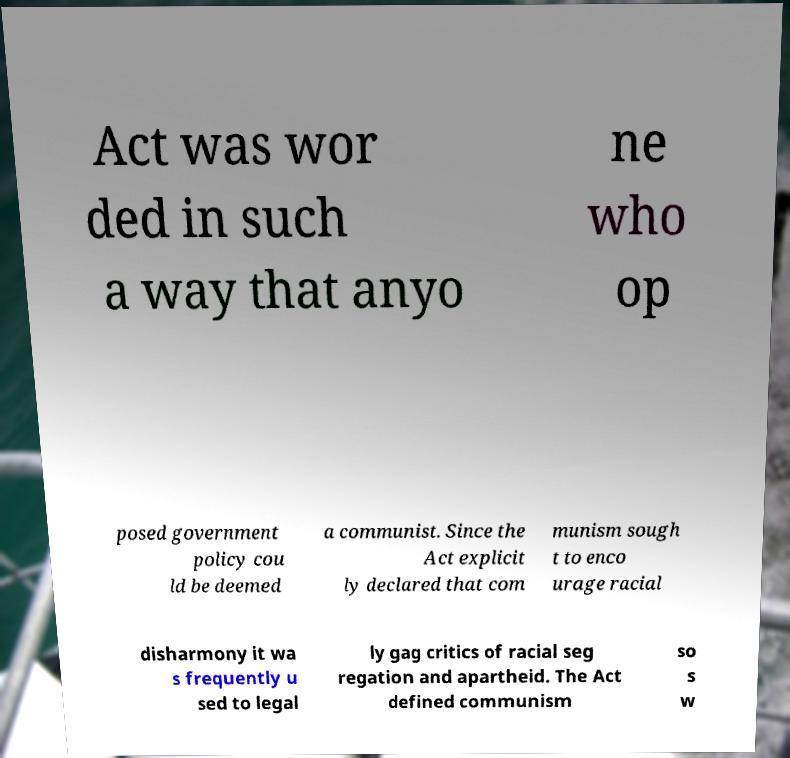There's text embedded in this image that I need extracted. Can you transcribe it verbatim? Act was wor ded in such a way that anyo ne who op posed government policy cou ld be deemed a communist. Since the Act explicit ly declared that com munism sough t to enco urage racial disharmony it wa s frequently u sed to legal ly gag critics of racial seg regation and apartheid. The Act defined communism so s w 